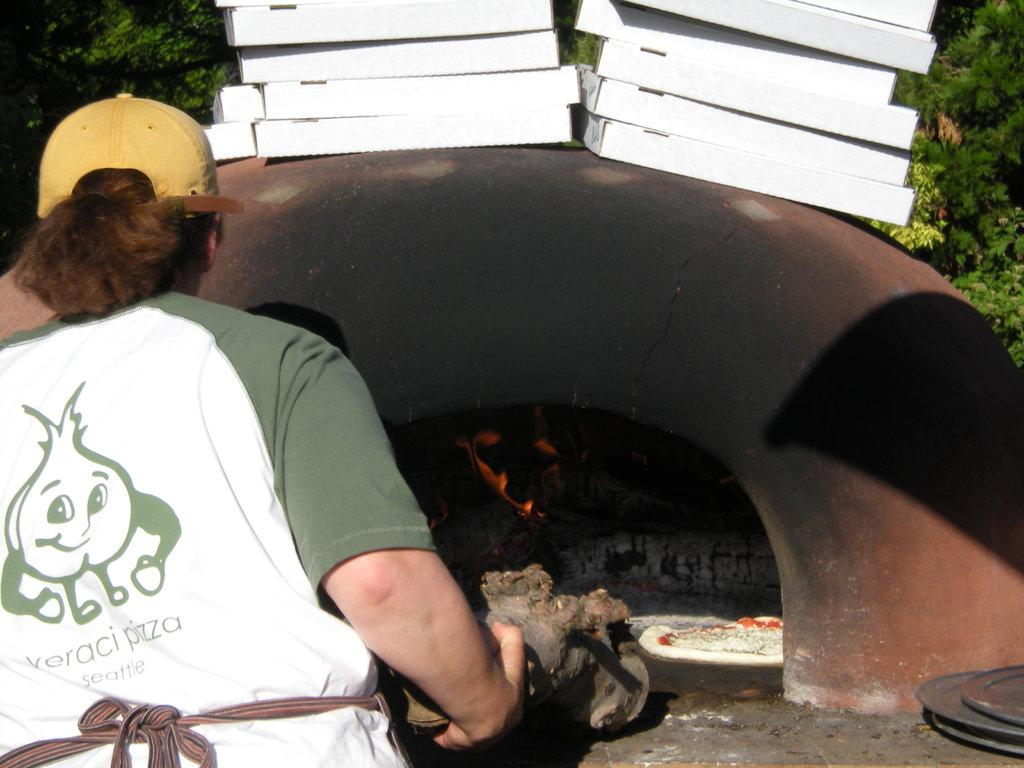<image>
Give a short and clear explanation of the subsequent image. A women is wearing a baseball cap and a t-shirt for a pizza place in Seattle. 